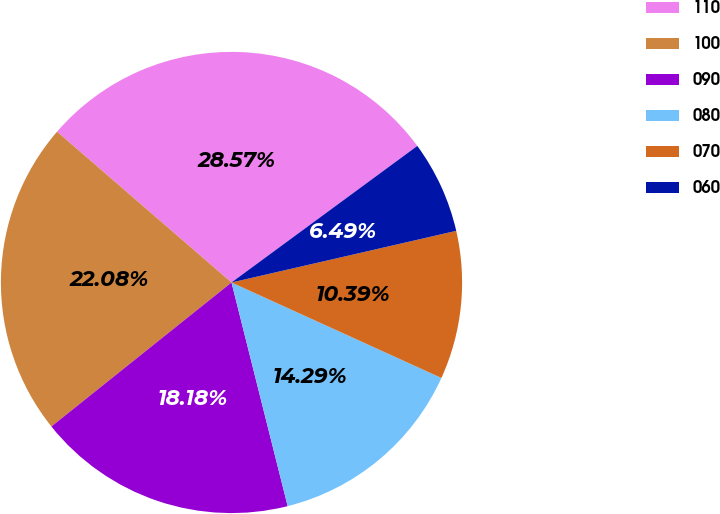Convert chart to OTSL. <chart><loc_0><loc_0><loc_500><loc_500><pie_chart><fcel>110<fcel>100<fcel>090<fcel>080<fcel>070<fcel>060<nl><fcel>28.57%<fcel>22.08%<fcel>18.18%<fcel>14.29%<fcel>10.39%<fcel>6.49%<nl></chart> 